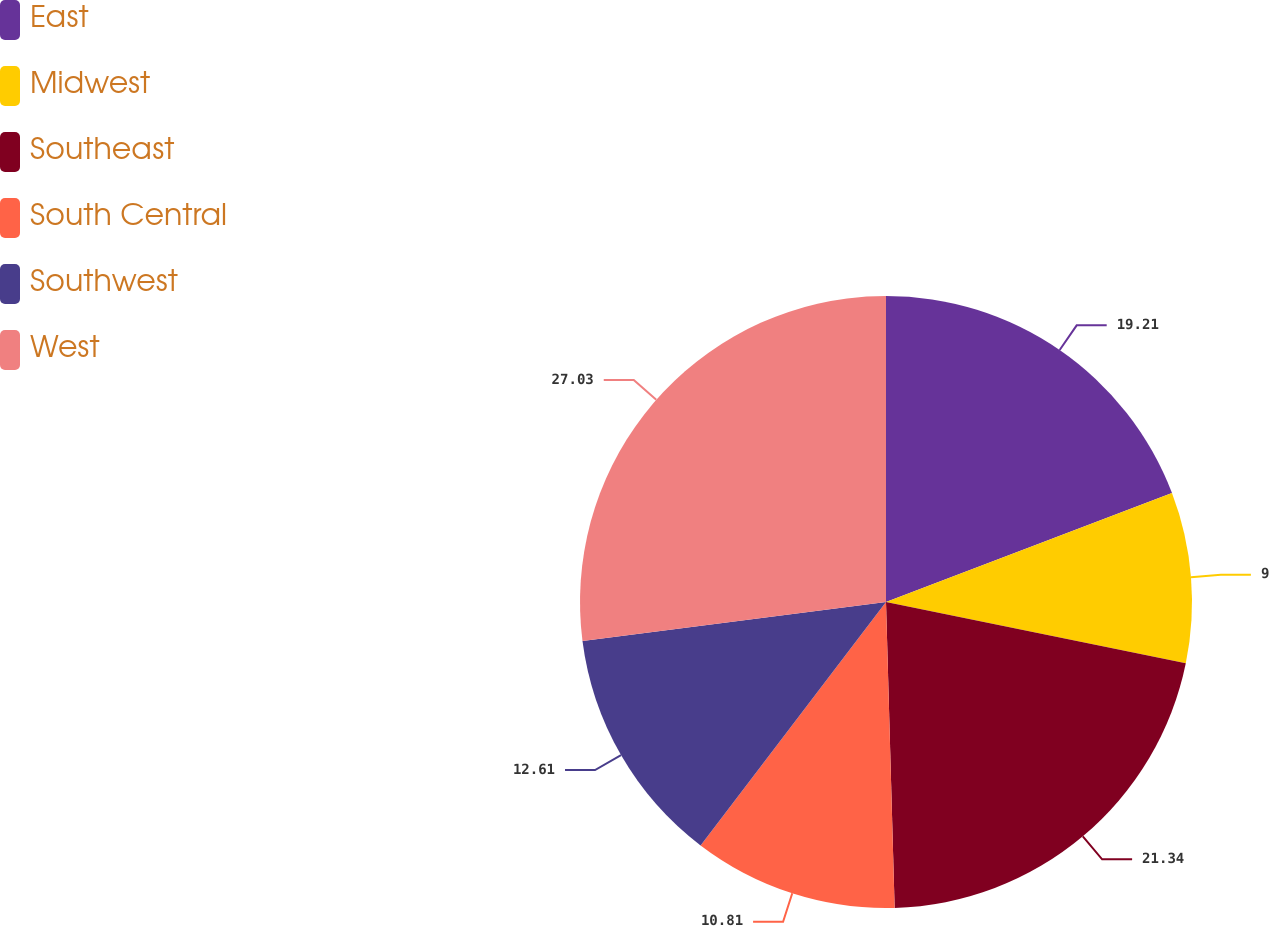Convert chart. <chart><loc_0><loc_0><loc_500><loc_500><pie_chart><fcel>East<fcel>Midwest<fcel>Southeast<fcel>South Central<fcel>Southwest<fcel>West<nl><fcel>19.21%<fcel>9.0%<fcel>21.34%<fcel>10.81%<fcel>12.61%<fcel>27.03%<nl></chart> 